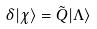Convert formula to latex. <formula><loc_0><loc_0><loc_500><loc_500>\delta | \chi \rangle = \tilde { Q } | \Lambda \rangle</formula> 